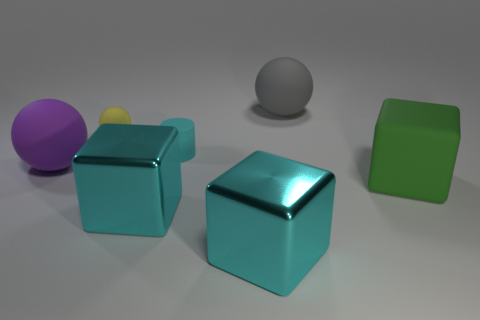Add 1 large purple cylinders. How many objects exist? 8 Subtract all big spheres. How many spheres are left? 1 Add 6 small yellow things. How many small yellow things are left? 7 Add 2 large gray rubber objects. How many large gray rubber objects exist? 3 Subtract all yellow spheres. How many spheres are left? 2 Subtract 0 red cylinders. How many objects are left? 7 Subtract all cylinders. How many objects are left? 6 Subtract 1 cylinders. How many cylinders are left? 0 Subtract all purple cylinders. Subtract all gray spheres. How many cylinders are left? 1 Subtract all blue cylinders. How many cyan cubes are left? 2 